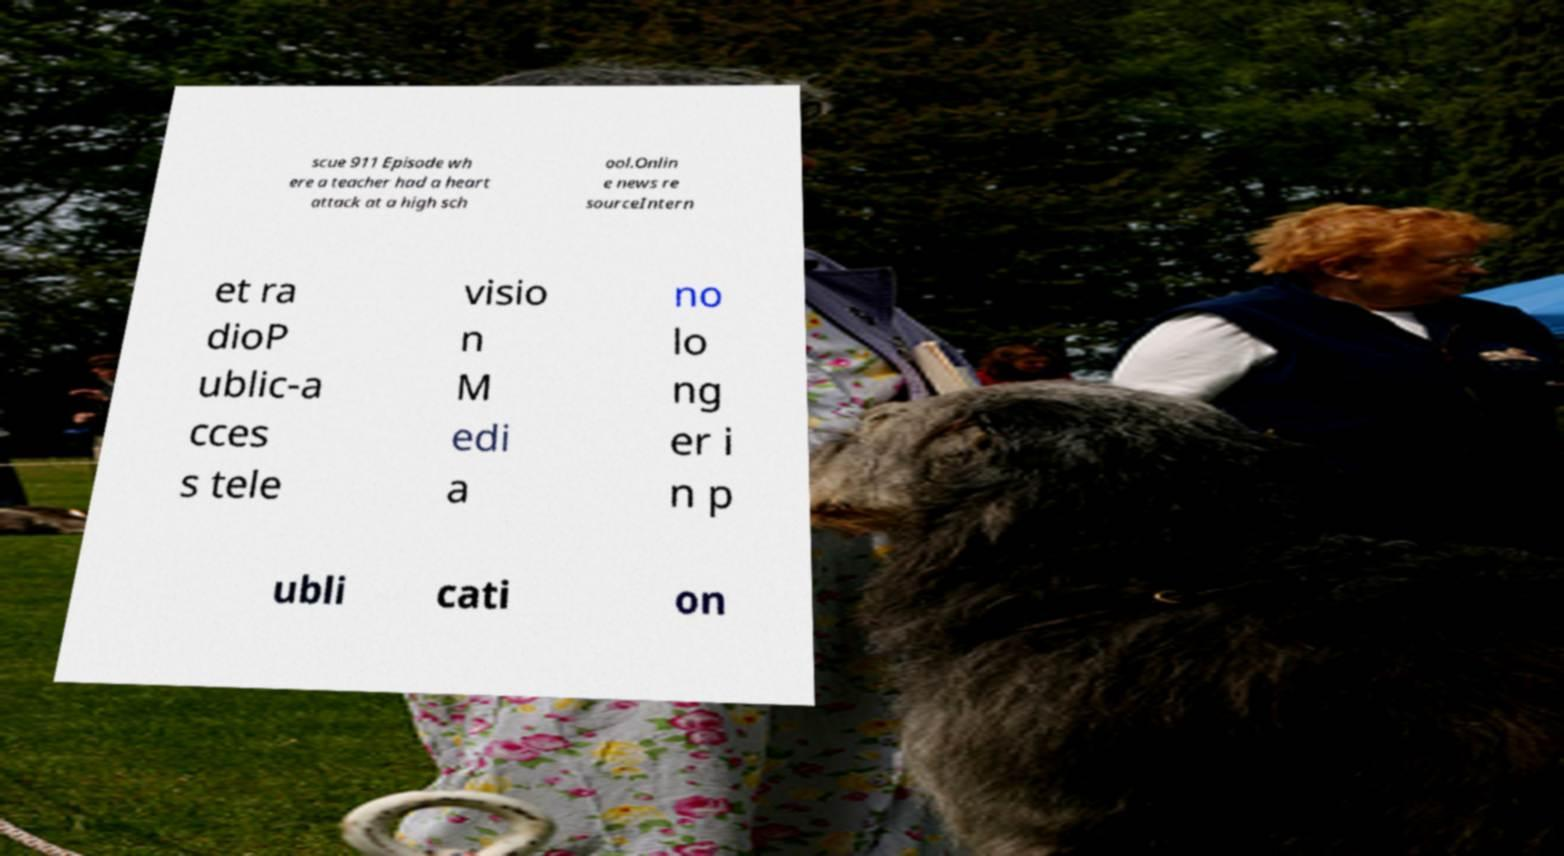There's text embedded in this image that I need extracted. Can you transcribe it verbatim? scue 911 Episode wh ere a teacher had a heart attack at a high sch ool.Onlin e news re sourceIntern et ra dioP ublic-a cces s tele visio n M edi a no lo ng er i n p ubli cati on 